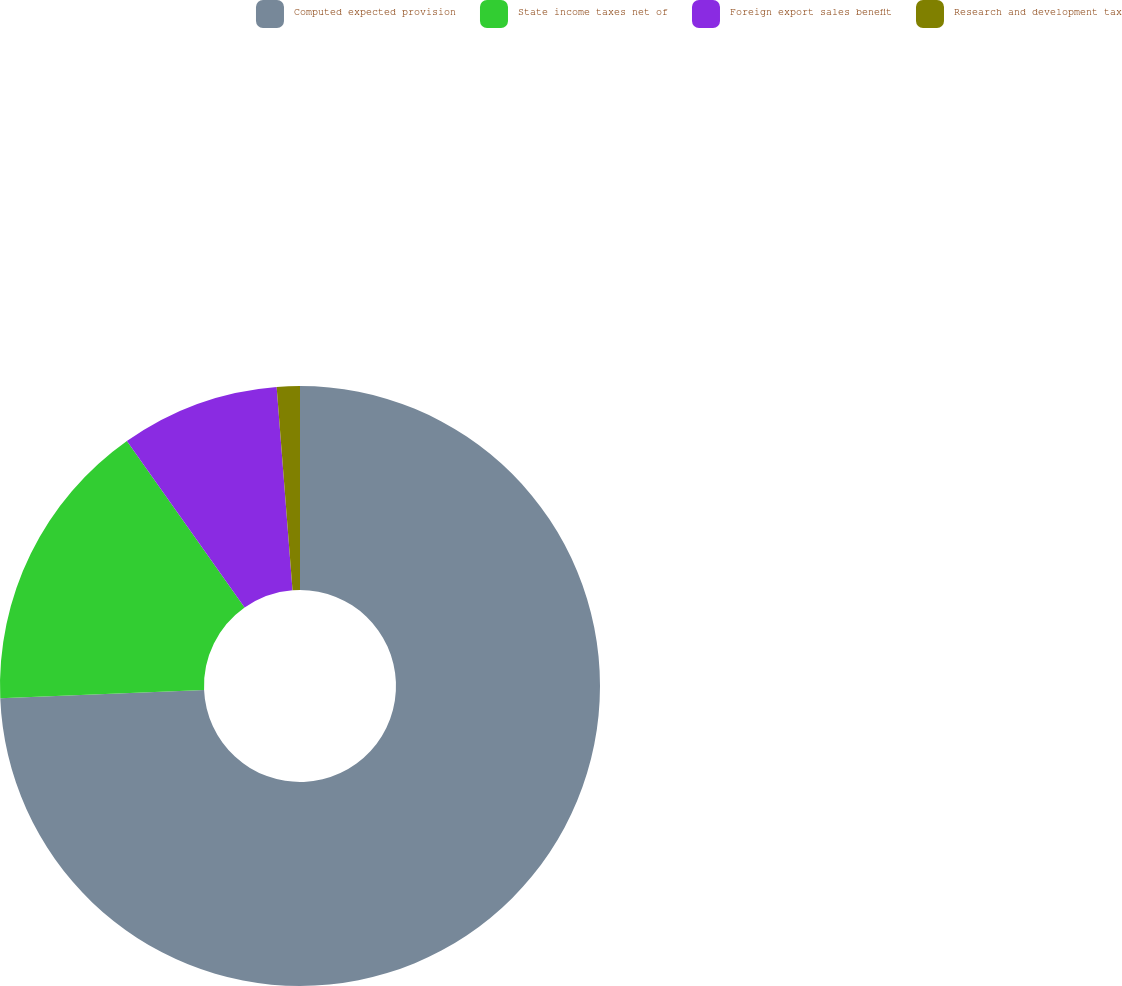Convert chart. <chart><loc_0><loc_0><loc_500><loc_500><pie_chart><fcel>Computed expected provision<fcel>State income taxes net of<fcel>Foreign export sales benefit<fcel>Research and development tax<nl><fcel>74.35%<fcel>15.86%<fcel>8.55%<fcel>1.24%<nl></chart> 